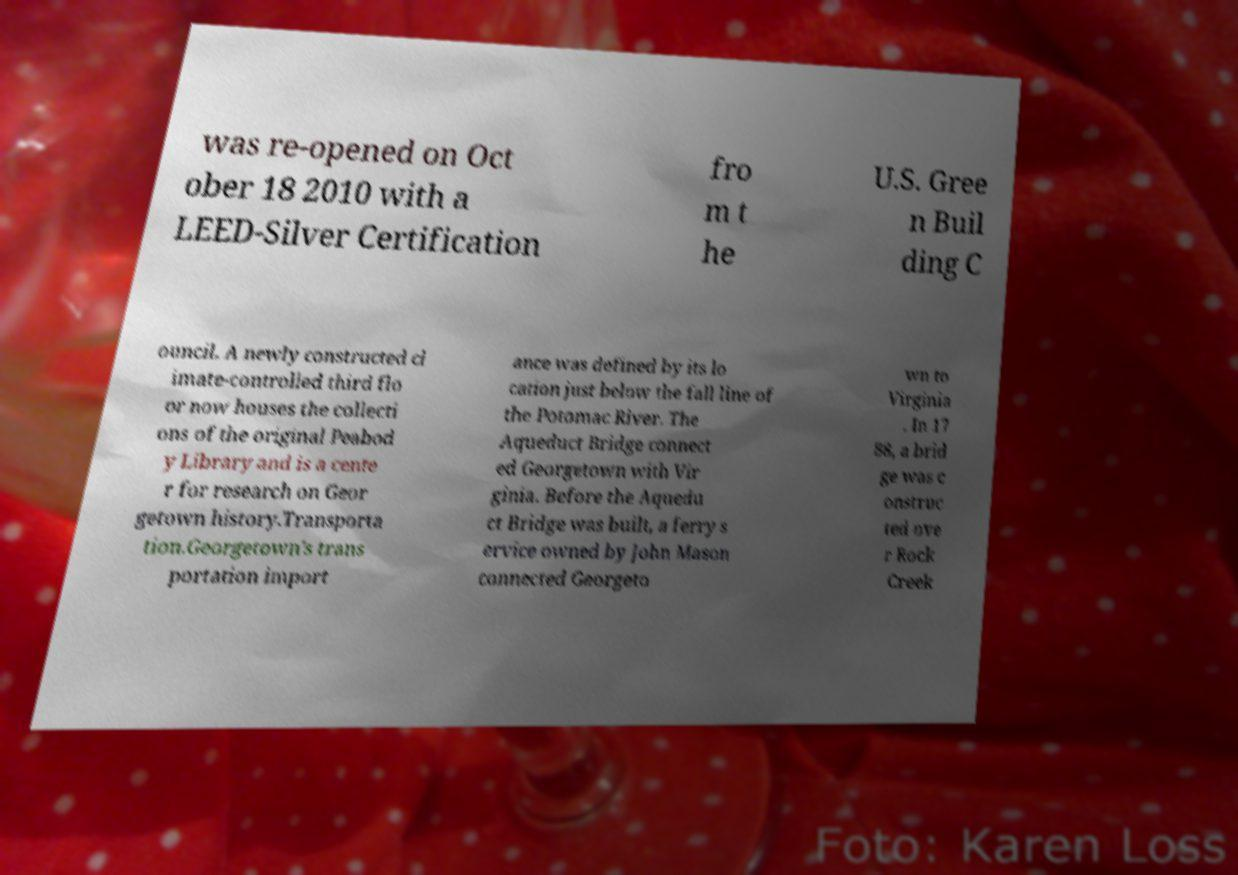Could you extract and type out the text from this image? was re-opened on Oct ober 18 2010 with a LEED-Silver Certification fro m t he U.S. Gree n Buil ding C ouncil. A newly constructed cl imate-controlled third flo or now houses the collecti ons of the original Peabod y Library and is a cente r for research on Geor getown history.Transporta tion.Georgetown's trans portation import ance was defined by its lo cation just below the fall line of the Potomac River. The Aqueduct Bridge connect ed Georgetown with Vir ginia. Before the Aquedu ct Bridge was built, a ferry s ervice owned by John Mason connected Georgeto wn to Virginia . In 17 88, a brid ge was c onstruc ted ove r Rock Creek 